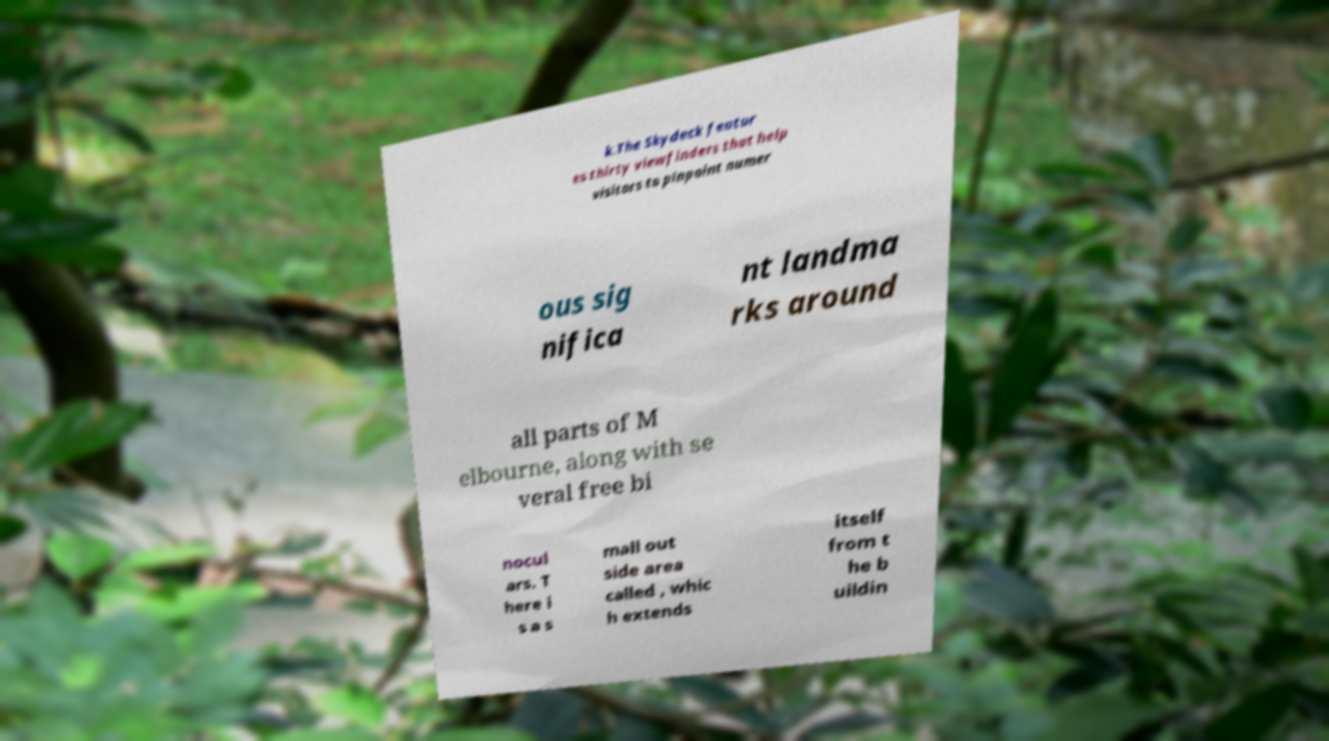Could you assist in decoding the text presented in this image and type it out clearly? k.The Skydeck featur es thirty viewfinders that help visitors to pinpoint numer ous sig nifica nt landma rks around all parts of M elbourne, along with se veral free bi nocul ars. T here i s a s mall out side area called , whic h extends itself from t he b uildin 